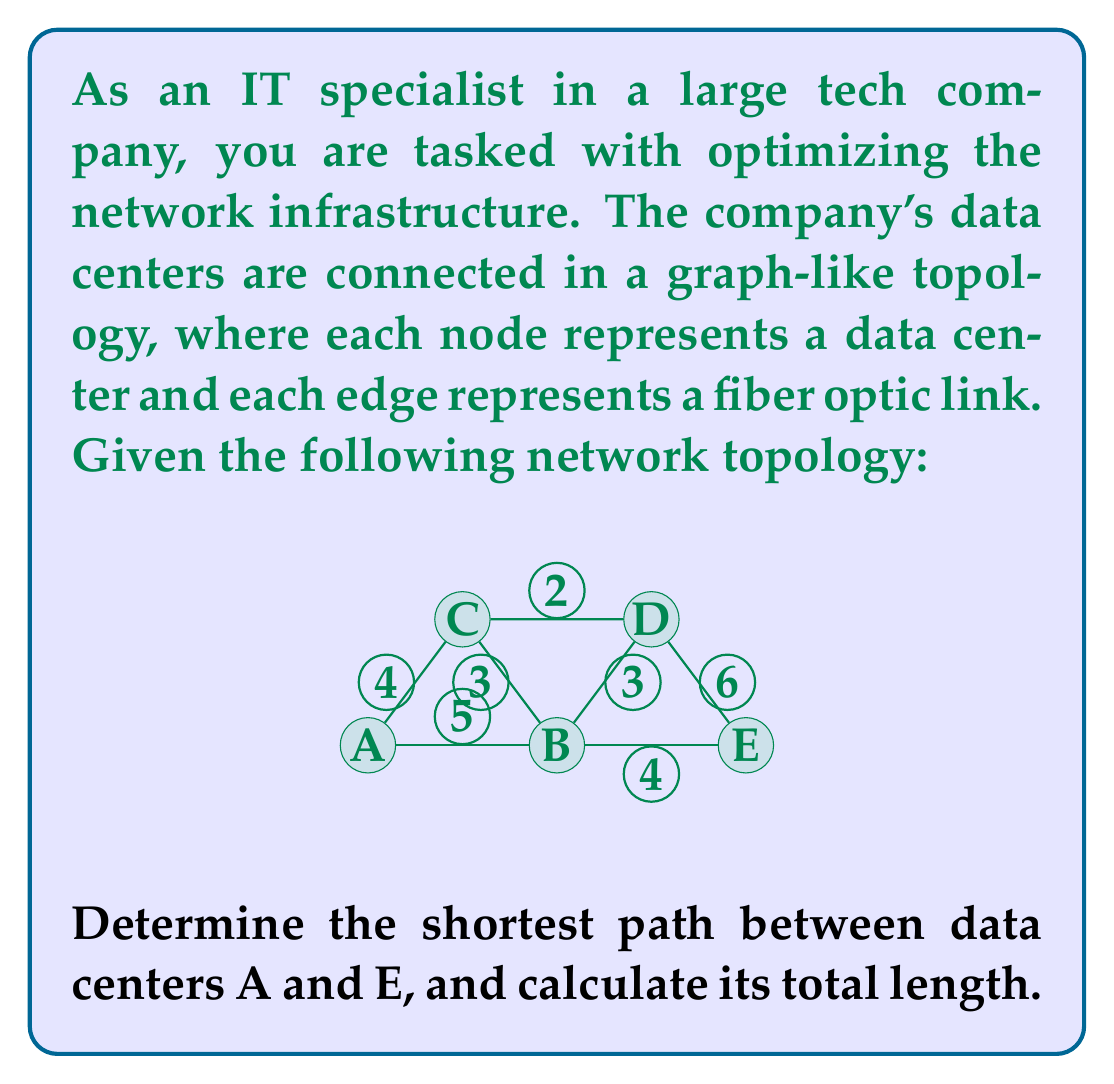Give your solution to this math problem. To solve this problem, we can use Dijkstra's algorithm, which is commonly used in network routing to find the shortest path between nodes in a graph.

Let's apply Dijkstra's algorithm step by step:

1) Initialize:
   - Set distance to A (start node) as 0
   - Set distances to all other nodes as infinity
   - Set all nodes as unvisited

2) For the current node (starting with A), consider all its unvisited neighbors and calculate their tentative distances.
   - A to B: 5
   - A to C: 4

3) Mark A as visited. The current known shortest distances are:
   A: 0, B: 5, C: 4, D: ∞, E: ∞

4) Select the unvisited node with the smallest tentative distance (C) and set it as the new current node.

5) For C, calculate distances to its neighbors:
   - C to B: 4 + 3 = 7 (longer than current B, so ignore)
   - C to D: 4 + 2 = 6

6) Mark C as visited. Updated distances:
   A: 0, B: 5, C: 4, D: 6, E: ∞

7) Select B as the new current node (smallest unvisited distance).

8) For B, calculate distances to its neighbors:
   - B to D: 5 + 3 = 8 (longer than current D, so ignore)
   - B to E: 5 + 4 = 9

9) Mark B as visited. Updated distances:
   A: 0, B: 5, C: 4, D: 6, E: 9

10) Select D as the new current node.

11) For D, calculate distance to E:
    - D to E: 6 + 6 = 12 (longer than current E, so ignore)

12) Mark D as visited. E is the only unvisited node left, so it becomes current.

13) Algorithm terminates as we've reached the target node E.

The shortest path from A to E is A -> C -> D -> E, with a total length of 4 + 2 + 6 = 12.
Answer: The shortest path from A to E is A -> C -> D -> E, with a total length of 12. 